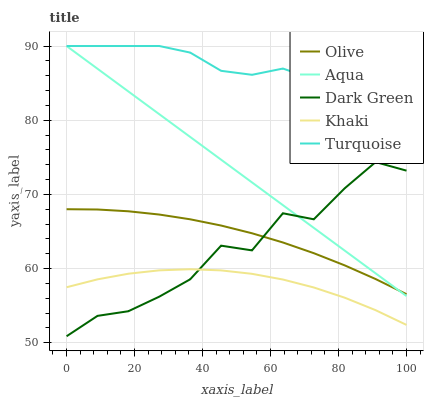Does Khaki have the minimum area under the curve?
Answer yes or no. Yes. Does Turquoise have the maximum area under the curve?
Answer yes or no. Yes. Does Turquoise have the minimum area under the curve?
Answer yes or no. No. Does Khaki have the maximum area under the curve?
Answer yes or no. No. Is Aqua the smoothest?
Answer yes or no. Yes. Is Dark Green the roughest?
Answer yes or no. Yes. Is Turquoise the smoothest?
Answer yes or no. No. Is Turquoise the roughest?
Answer yes or no. No. Does Dark Green have the lowest value?
Answer yes or no. Yes. Does Khaki have the lowest value?
Answer yes or no. No. Does Aqua have the highest value?
Answer yes or no. Yes. Does Khaki have the highest value?
Answer yes or no. No. Is Dark Green less than Turquoise?
Answer yes or no. Yes. Is Aqua greater than Khaki?
Answer yes or no. Yes. Does Olive intersect Dark Green?
Answer yes or no. Yes. Is Olive less than Dark Green?
Answer yes or no. No. Is Olive greater than Dark Green?
Answer yes or no. No. Does Dark Green intersect Turquoise?
Answer yes or no. No. 